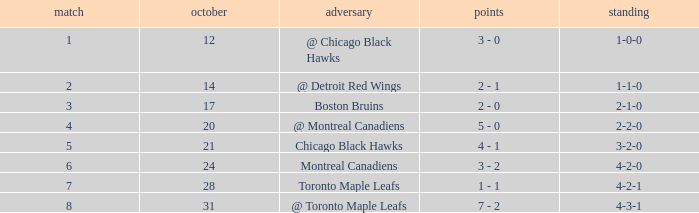What was the score of the game after game 6 on October 28? 1 - 1. 